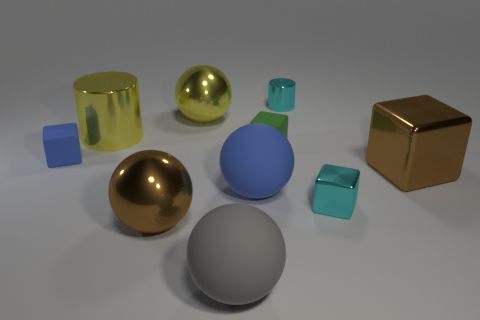Is the size of the cyan metallic cylinder the same as the metallic cylinder to the left of the tiny cyan metal cylinder?
Your response must be concise. No. What number of gray things are there?
Provide a short and direct response. 1. How many blue objects are either blocks or big blocks?
Your answer should be very brief. 1. Are the blue thing to the right of the brown metallic ball and the large yellow ball made of the same material?
Ensure brevity in your answer.  No. What number of other things are the same material as the small cyan cylinder?
Your answer should be compact. 5. What is the material of the tiny green thing?
Keep it short and to the point. Rubber. There is a cyan thing that is behind the small metal cube; what is its size?
Your response must be concise. Small. What number of large rubber balls are behind the large brown shiny thing that is left of the gray sphere?
Make the answer very short. 1. Does the tiny cyan metal object that is behind the large brown metallic block have the same shape as the blue thing that is left of the gray ball?
Your response must be concise. No. What number of cubes are right of the gray rubber sphere and on the left side of the large cylinder?
Keep it short and to the point. 0. 